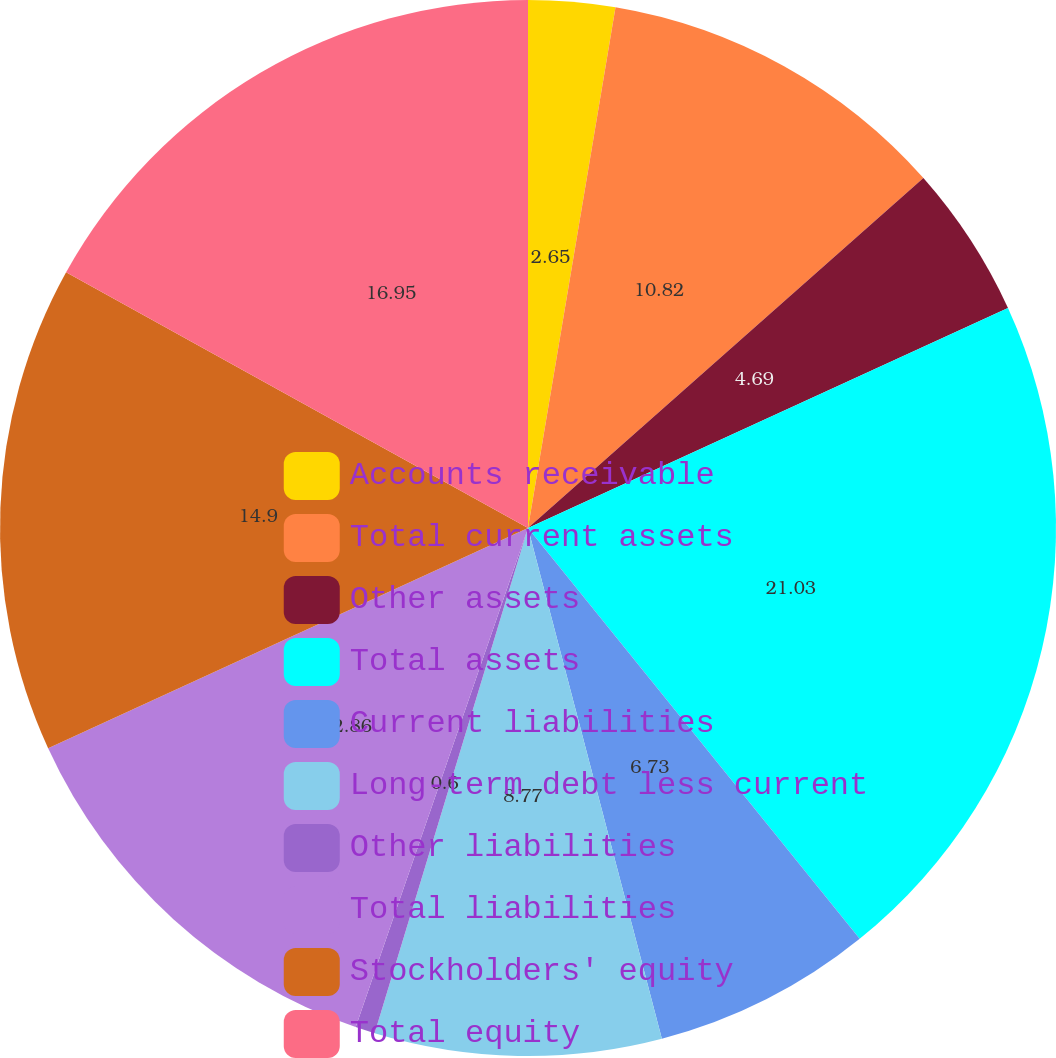Convert chart. <chart><loc_0><loc_0><loc_500><loc_500><pie_chart><fcel>Accounts receivable<fcel>Total current assets<fcel>Other assets<fcel>Total assets<fcel>Current liabilities<fcel>Long-term debt less current<fcel>Other liabilities<fcel>Total liabilities<fcel>Stockholders' equity<fcel>Total equity<nl><fcel>2.65%<fcel>10.82%<fcel>4.69%<fcel>21.03%<fcel>6.73%<fcel>8.77%<fcel>0.6%<fcel>12.86%<fcel>14.9%<fcel>16.95%<nl></chart> 